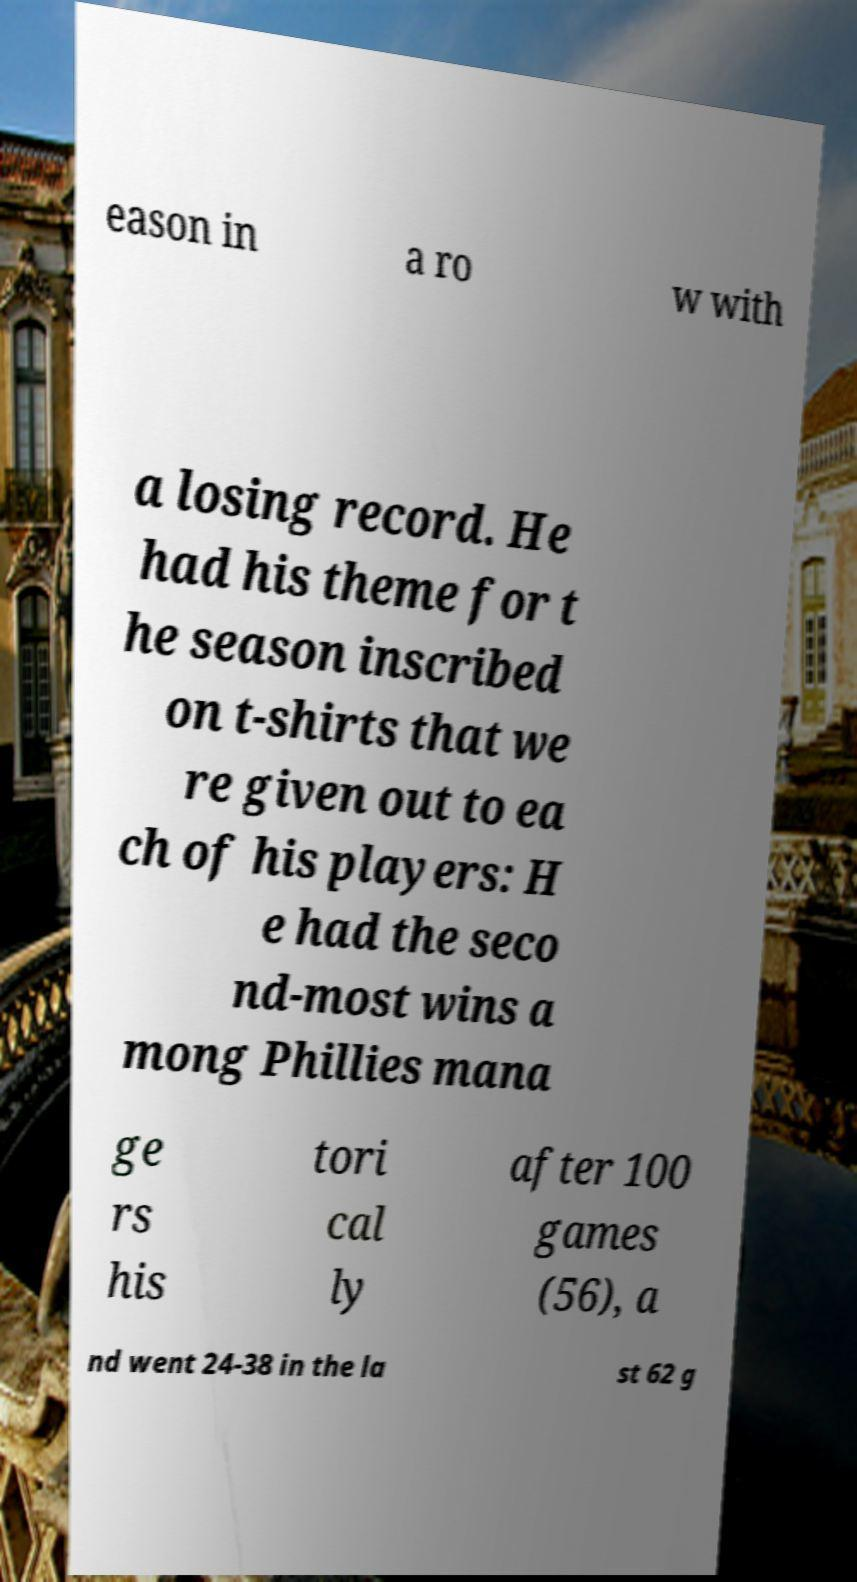Please read and relay the text visible in this image. What does it say? eason in a ro w with a losing record. He had his theme for t he season inscribed on t-shirts that we re given out to ea ch of his players: H e had the seco nd-most wins a mong Phillies mana ge rs his tori cal ly after 100 games (56), a nd went 24-38 in the la st 62 g 